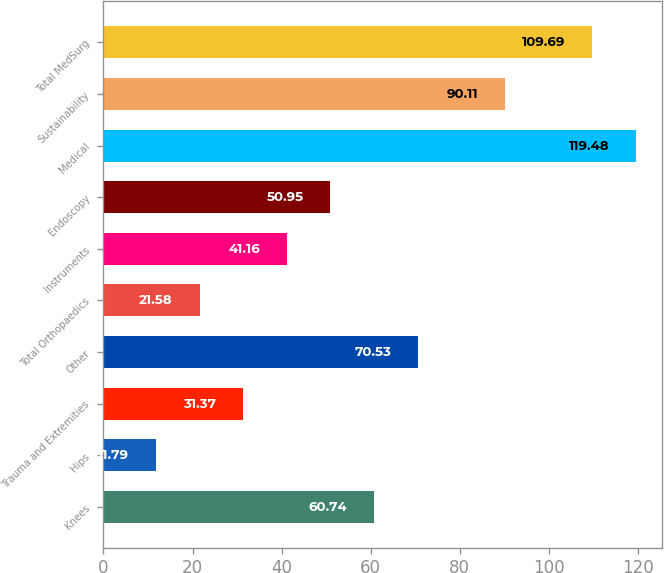Convert chart to OTSL. <chart><loc_0><loc_0><loc_500><loc_500><bar_chart><fcel>Knees<fcel>Hips<fcel>Trauma and Extremities<fcel>Other<fcel>Total Orthopaedics<fcel>Instruments<fcel>Endoscopy<fcel>Medical<fcel>Sustainability<fcel>Total MedSurg<nl><fcel>60.74<fcel>11.79<fcel>31.37<fcel>70.53<fcel>21.58<fcel>41.16<fcel>50.95<fcel>119.48<fcel>90.11<fcel>109.69<nl></chart> 